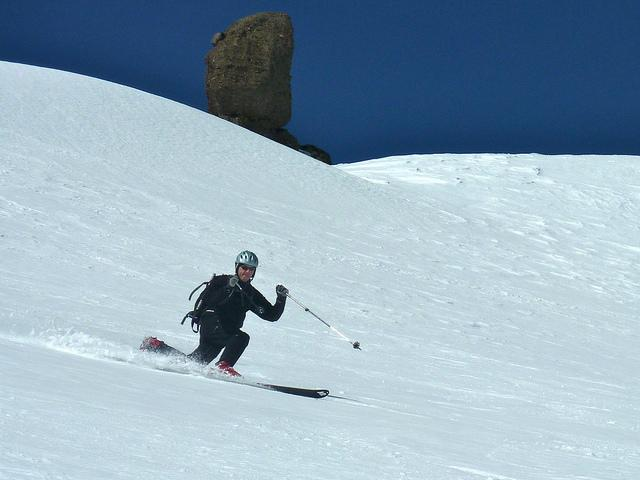Why is the man wearing the silver helmet? protection 